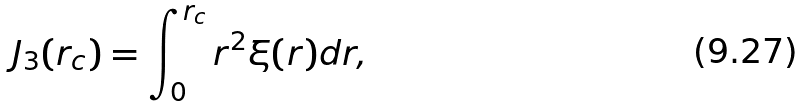<formula> <loc_0><loc_0><loc_500><loc_500>J _ { 3 } ( r _ { c } ) = \int _ { 0 } ^ { r _ { c } } r ^ { 2 } \xi ( r ) d r ,</formula> 